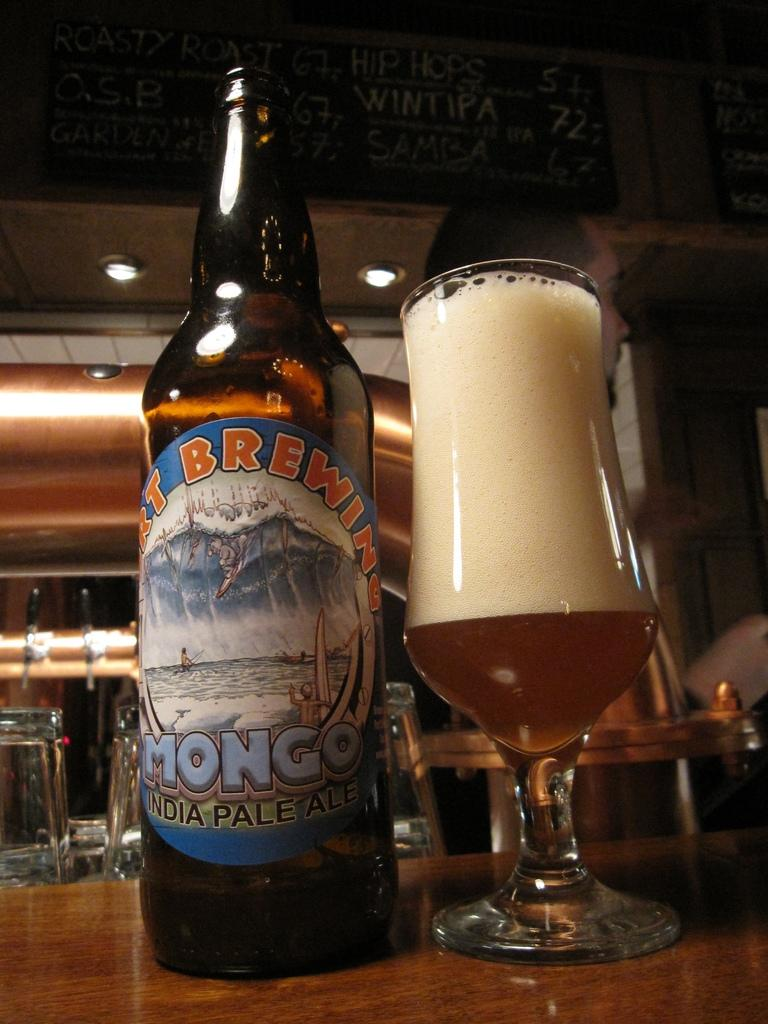<image>
Describe the image concisely. A bottle of India pale ale sits next to a full glass. 